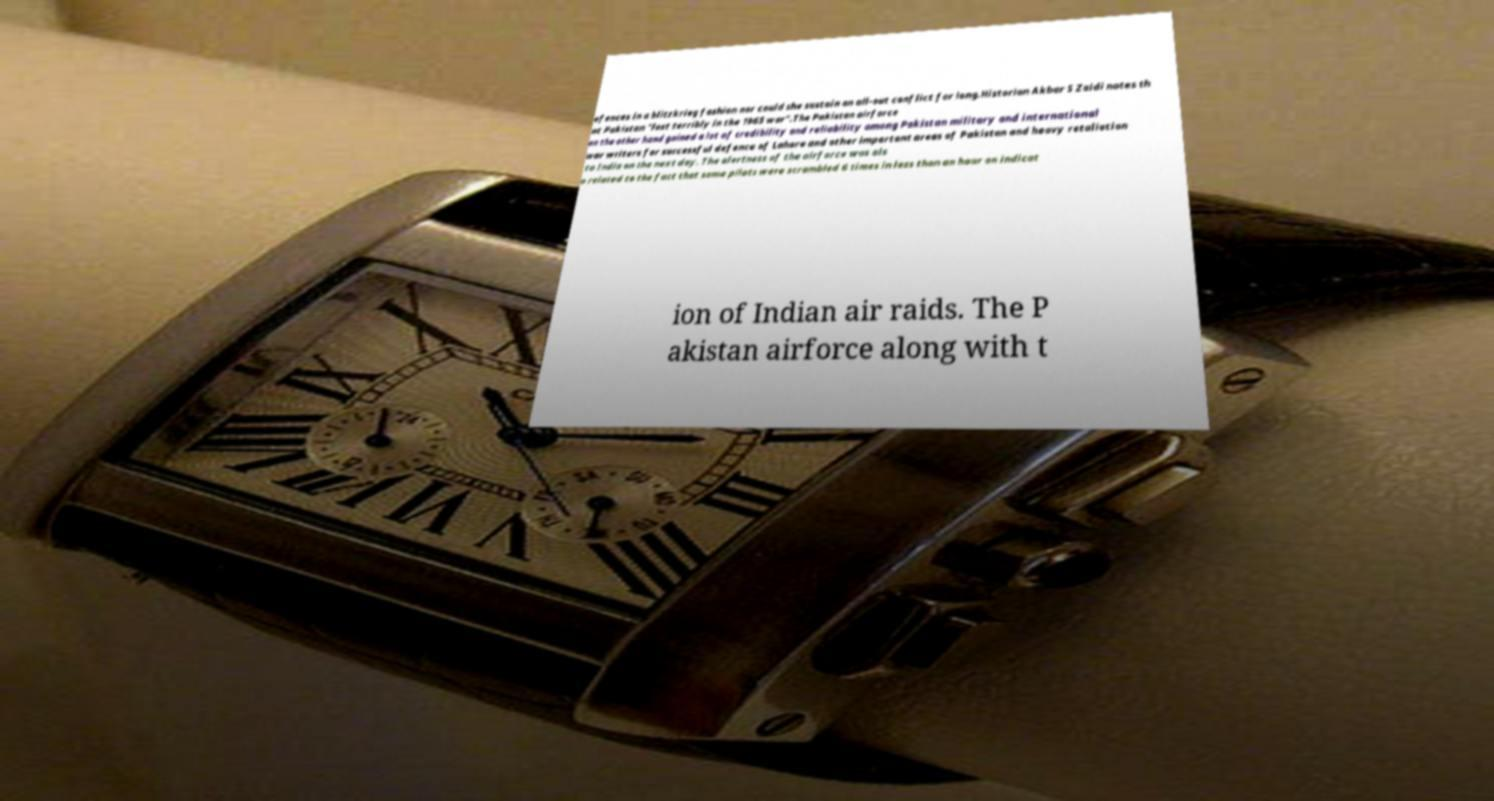What messages or text are displayed in this image? I need them in a readable, typed format. efences in a blitzkrieg fashion nor could she sustain an all-out conflict for long.Historian Akbar S Zaidi notes th at Pakistan "lost terribly in the 1965 war".The Pakistan airforce on the other hand gained a lot of credibility and reliability among Pakistan military and international war writers for successful defence of Lahore and other important areas of Pakistan and heavy retaliation to India on the next day. The alertness of the airforce was als o related to the fact that some pilots were scrambled 6 times in less than an hour on indicat ion of Indian air raids. The P akistan airforce along with t 